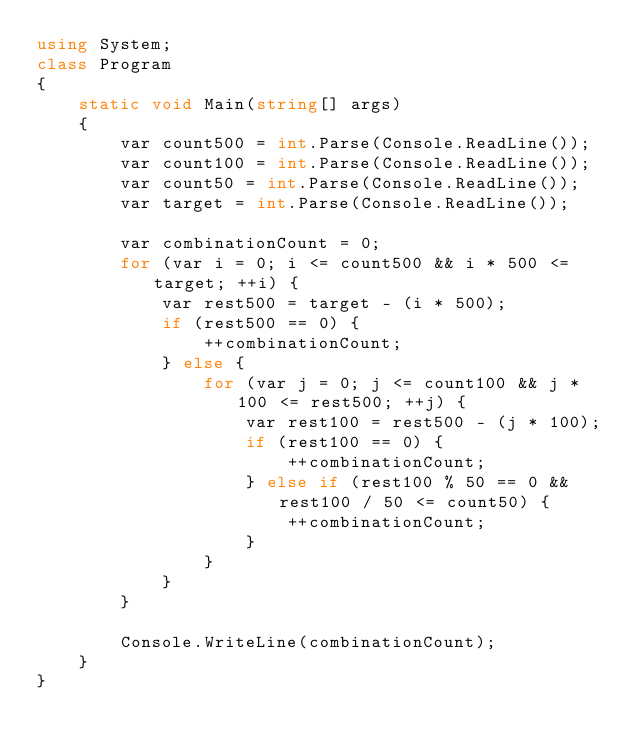<code> <loc_0><loc_0><loc_500><loc_500><_C#_>using System;
class Program
{
	static void Main(string[] args)
	{
		var count500 = int.Parse(Console.ReadLine());
		var count100 = int.Parse(Console.ReadLine());
		var count50 = int.Parse(Console.ReadLine());
		var target = int.Parse(Console.ReadLine());

		var combinationCount = 0;
		for (var i = 0; i <= count500 && i * 500 <= target; ++i) {
			var rest500 = target - (i * 500);
			if (rest500 == 0) {
				++combinationCount;
			} else {
				for (var j = 0; j <= count100 && j * 100 <= rest500; ++j) {
					var rest100 = rest500 - (j * 100);
					if (rest100 == 0) {
						++combinationCount;
					} else if (rest100 % 50 == 0 && rest100 / 50 <= count50) {
						++combinationCount;
					}
				}
			}
		}

		Console.WriteLine(combinationCount);
	}
}</code> 